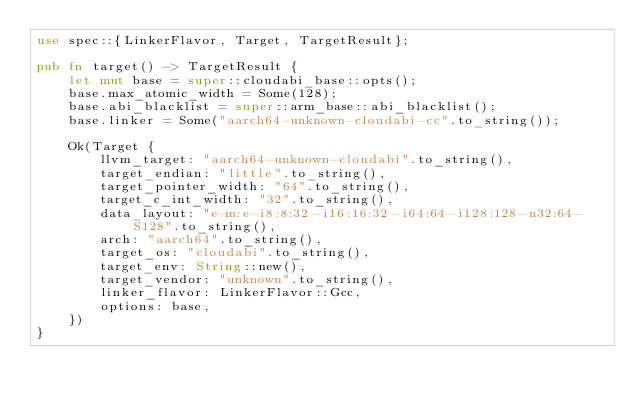Convert code to text. <code><loc_0><loc_0><loc_500><loc_500><_Rust_>use spec::{LinkerFlavor, Target, TargetResult};

pub fn target() -> TargetResult {
    let mut base = super::cloudabi_base::opts();
    base.max_atomic_width = Some(128);
    base.abi_blacklist = super::arm_base::abi_blacklist();
    base.linker = Some("aarch64-unknown-cloudabi-cc".to_string());

    Ok(Target {
        llvm_target: "aarch64-unknown-cloudabi".to_string(),
        target_endian: "little".to_string(),
        target_pointer_width: "64".to_string(),
        target_c_int_width: "32".to_string(),
        data_layout: "e-m:e-i8:8:32-i16:16:32-i64:64-i128:128-n32:64-S128".to_string(),
        arch: "aarch64".to_string(),
        target_os: "cloudabi".to_string(),
        target_env: String::new(),
        target_vendor: "unknown".to_string(),
        linker_flavor: LinkerFlavor::Gcc,
        options: base,
    })
}
</code> 